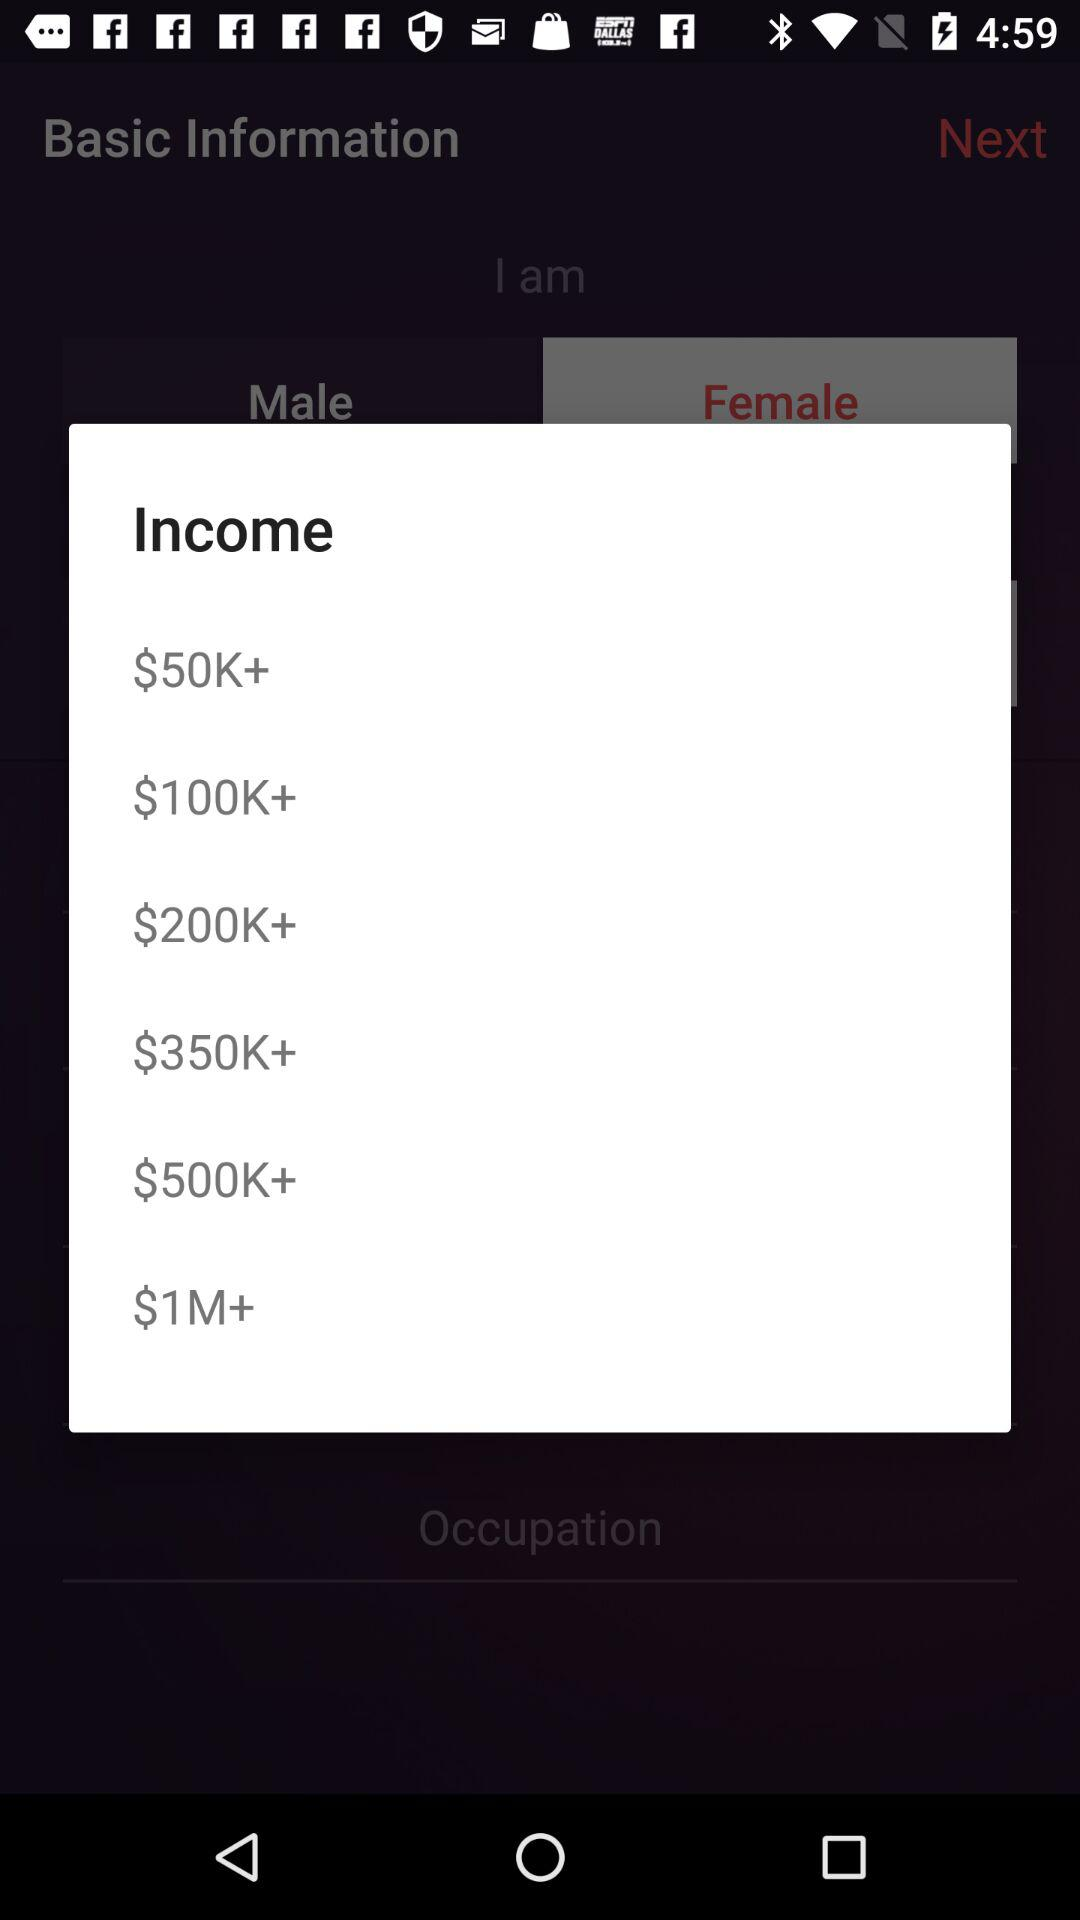How many income ranges are there?
Answer the question using a single word or phrase. 6 